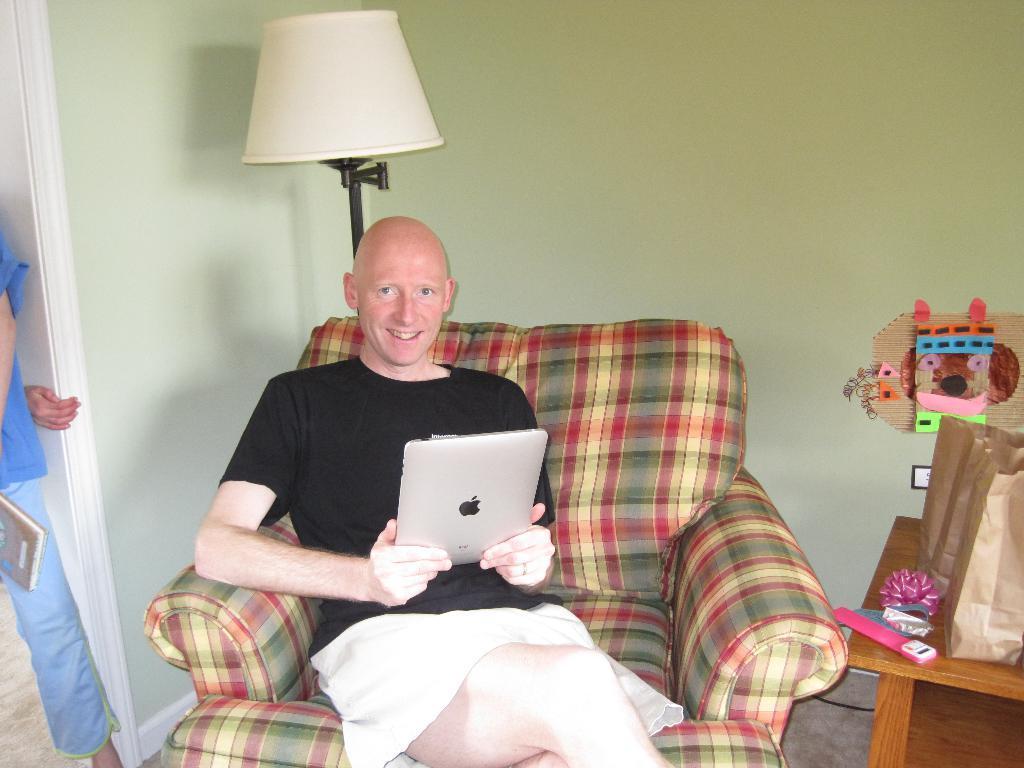Please provide a concise description of this image. In the picture there is a man sitting on the sofa chair and holding a laptop with the hand, behind there is a table lamp, there is a wall, beside there is a table, there are some items on the table, there may be a person standing. 